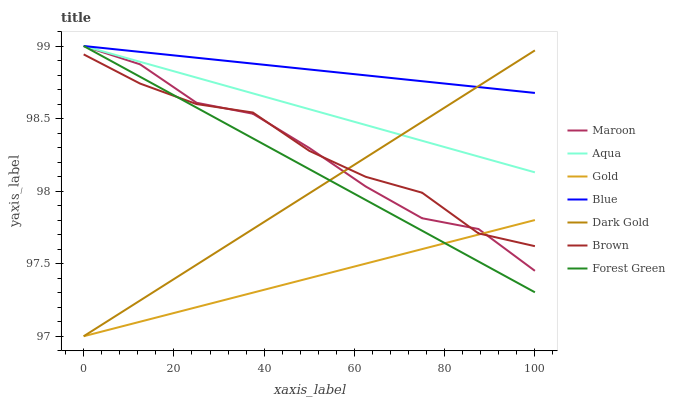Does Gold have the minimum area under the curve?
Answer yes or no. Yes. Does Blue have the maximum area under the curve?
Answer yes or no. Yes. Does Brown have the minimum area under the curve?
Answer yes or no. No. Does Brown have the maximum area under the curve?
Answer yes or no. No. Is Dark Gold the smoothest?
Answer yes or no. Yes. Is Maroon the roughest?
Answer yes or no. Yes. Is Brown the smoothest?
Answer yes or no. No. Is Brown the roughest?
Answer yes or no. No. Does Gold have the lowest value?
Answer yes or no. Yes. Does Brown have the lowest value?
Answer yes or no. No. Does Forest Green have the highest value?
Answer yes or no. Yes. Does Brown have the highest value?
Answer yes or no. No. Is Gold less than Aqua?
Answer yes or no. Yes. Is Aqua greater than Brown?
Answer yes or no. Yes. Does Forest Green intersect Blue?
Answer yes or no. Yes. Is Forest Green less than Blue?
Answer yes or no. No. Is Forest Green greater than Blue?
Answer yes or no. No. Does Gold intersect Aqua?
Answer yes or no. No. 